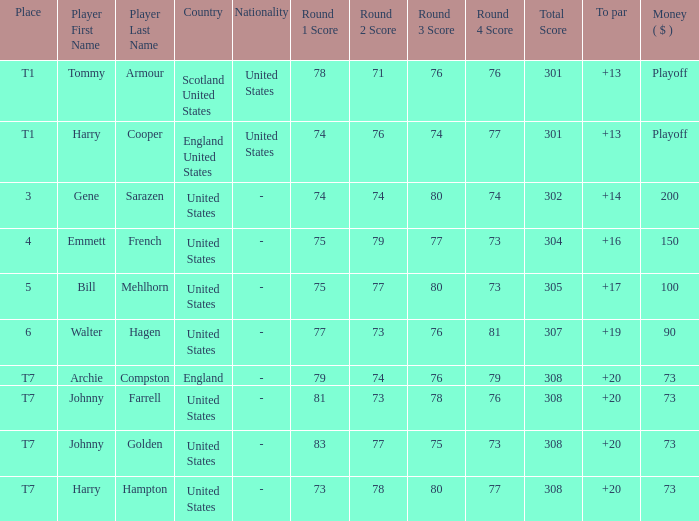What country features a to par less than 19 with a combined score of 75-79-77-73=304? United States. 